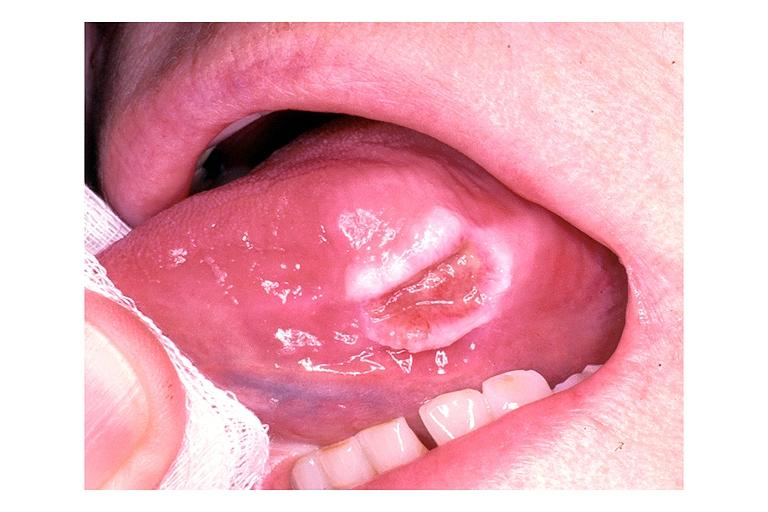what does this image show?
Answer the question using a single word or phrase. Traumatic ulcer 